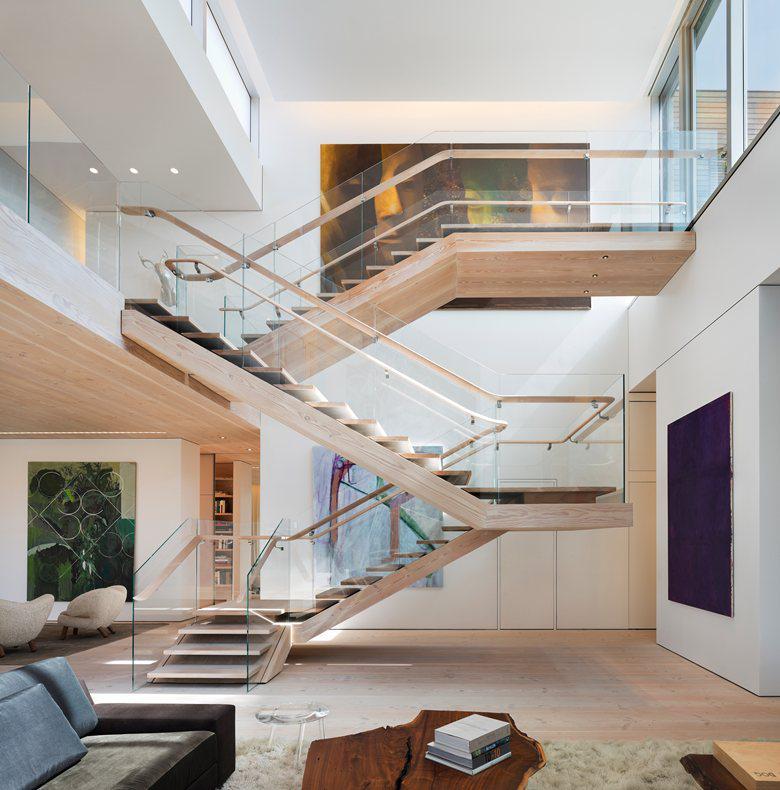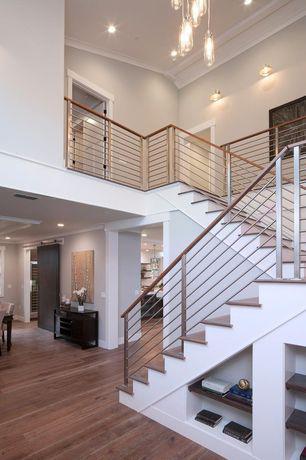The first image is the image on the left, the second image is the image on the right. Considering the images on both sides, is "The end of white-faced built-in shelves can be seen in the angled space under a set of stairs in one image." valid? Answer yes or no. Yes. The first image is the image on the left, the second image is the image on the right. Examine the images to the left and right. Is the description "One image shows a staircase leading down to the right, with glass panels along the side and flat brown wooden backless steps." accurate? Answer yes or no. No. 